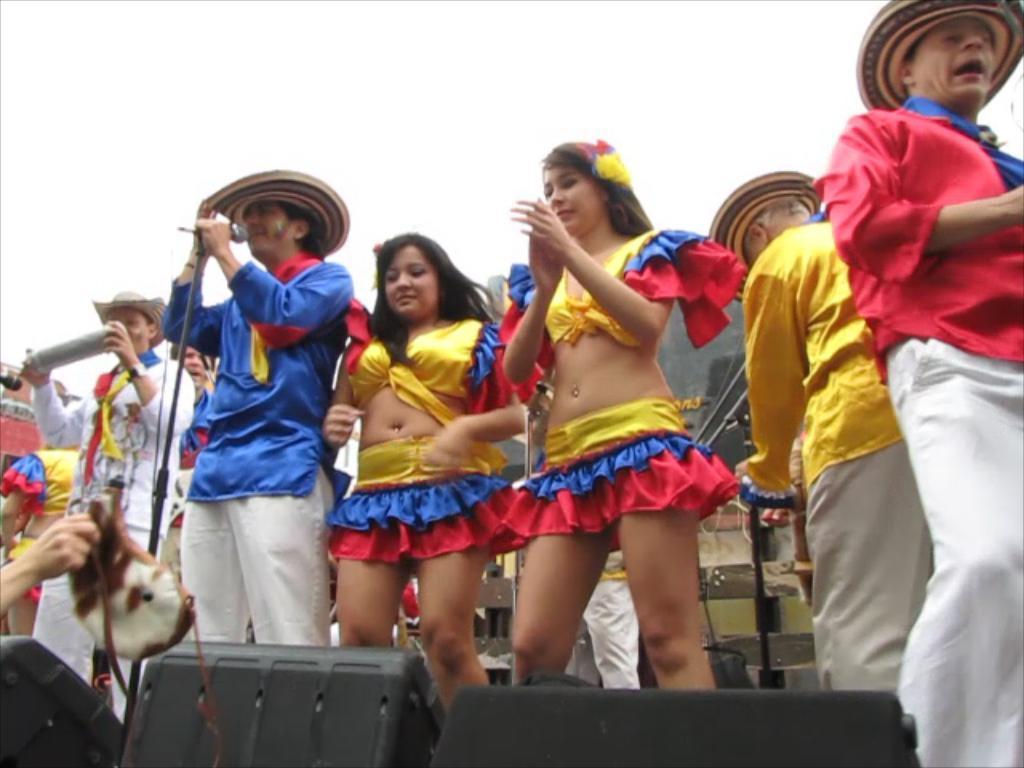Can you describe this image briefly? In this image there are group of persons performing on the stage. In the front there are objects which are black in colour and there are musical instruments on the stage. 